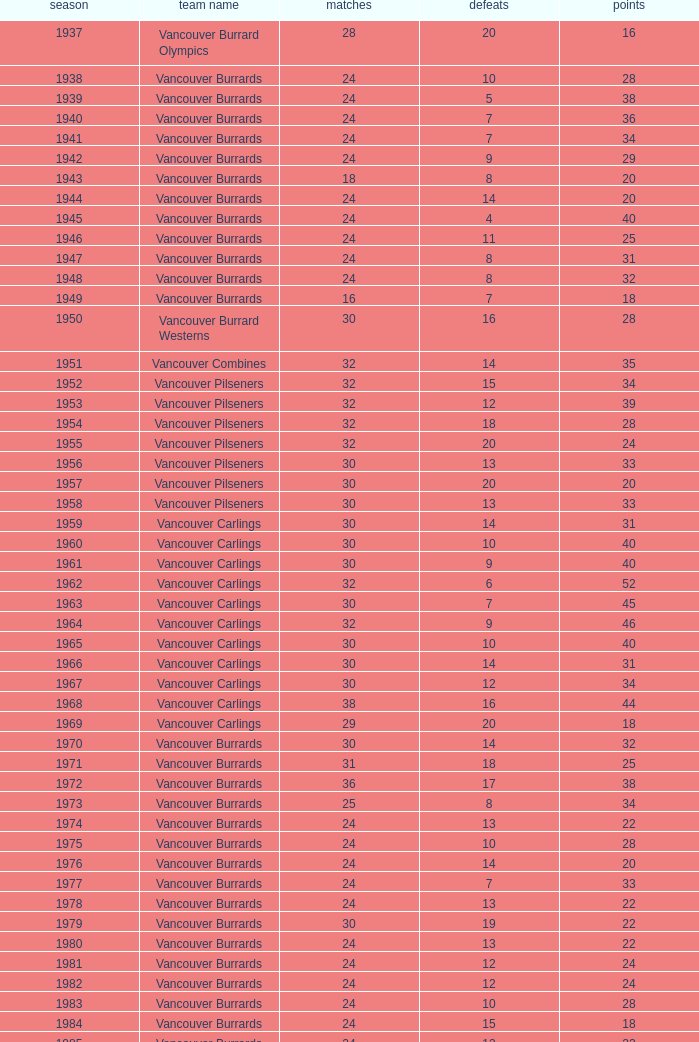What's the lowest number of points with fewer than 8 losses and fewer than 24 games for the vancouver burrards? 18.0. 